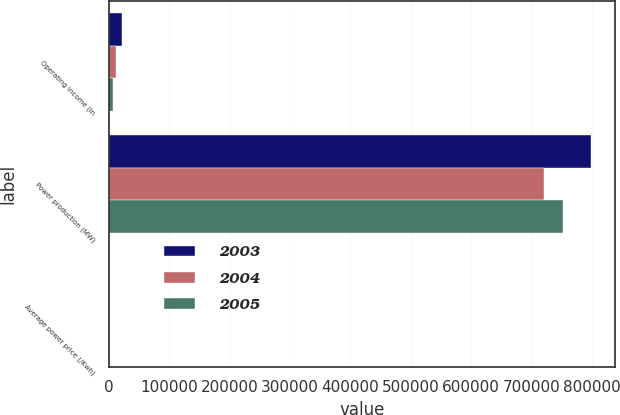Convert chart. <chart><loc_0><loc_0><loc_500><loc_500><stacked_bar_chart><ecel><fcel>Operating income (in<fcel>Power production (MW)<fcel>Average power price (/Kwh)<nl><fcel>2003<fcel>21091<fcel>799160<fcel>0.09<nl><fcel>2004<fcel>10839<fcel>720300<fcel>0.08<nl><fcel>2005<fcel>7176<fcel>751689<fcel>0.08<nl></chart> 